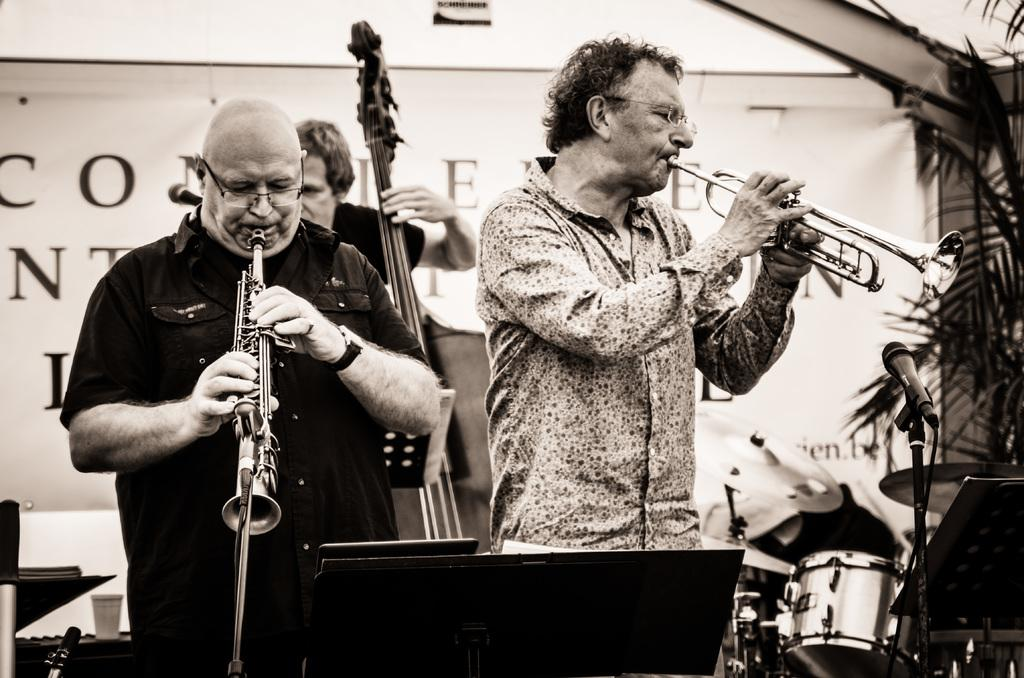How many people are playing musical instruments in the image? There are three persons playing musical instruments in the image. What else can be seen in the image besides the people playing instruments? Plants are visible in the image. What is present in the background of the image? There is a banner in the background of the image. What is the color scheme of the image? The image is in black and white. Can you see any chickens in the image? No, there are no chickens present in the image. What type of collar is the person wearing in the image? There is no collar visible in the image, as it is in black and white and does not show any clothing details. 